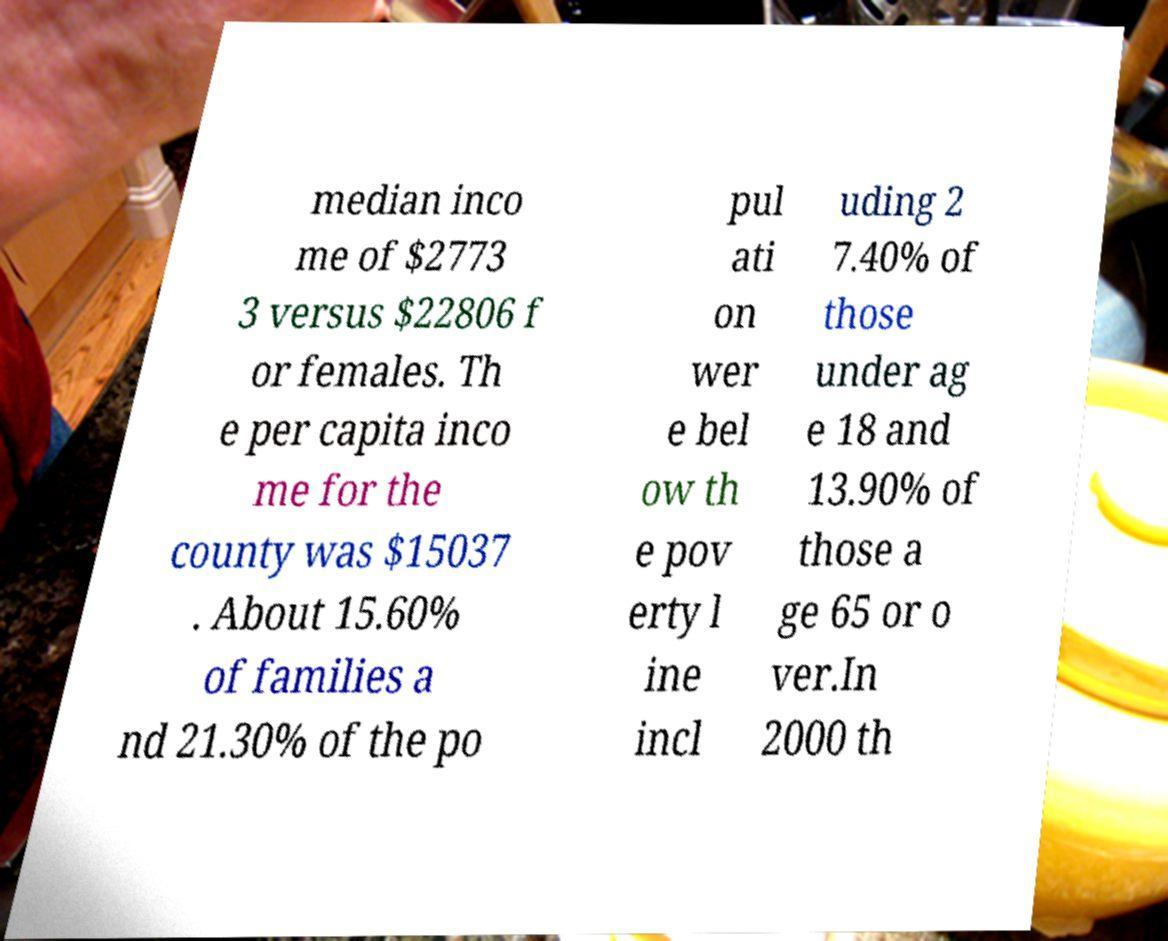Please identify and transcribe the text found in this image. median inco me of $2773 3 versus $22806 f or females. Th e per capita inco me for the county was $15037 . About 15.60% of families a nd 21.30% of the po pul ati on wer e bel ow th e pov erty l ine incl uding 2 7.40% of those under ag e 18 and 13.90% of those a ge 65 or o ver.In 2000 th 